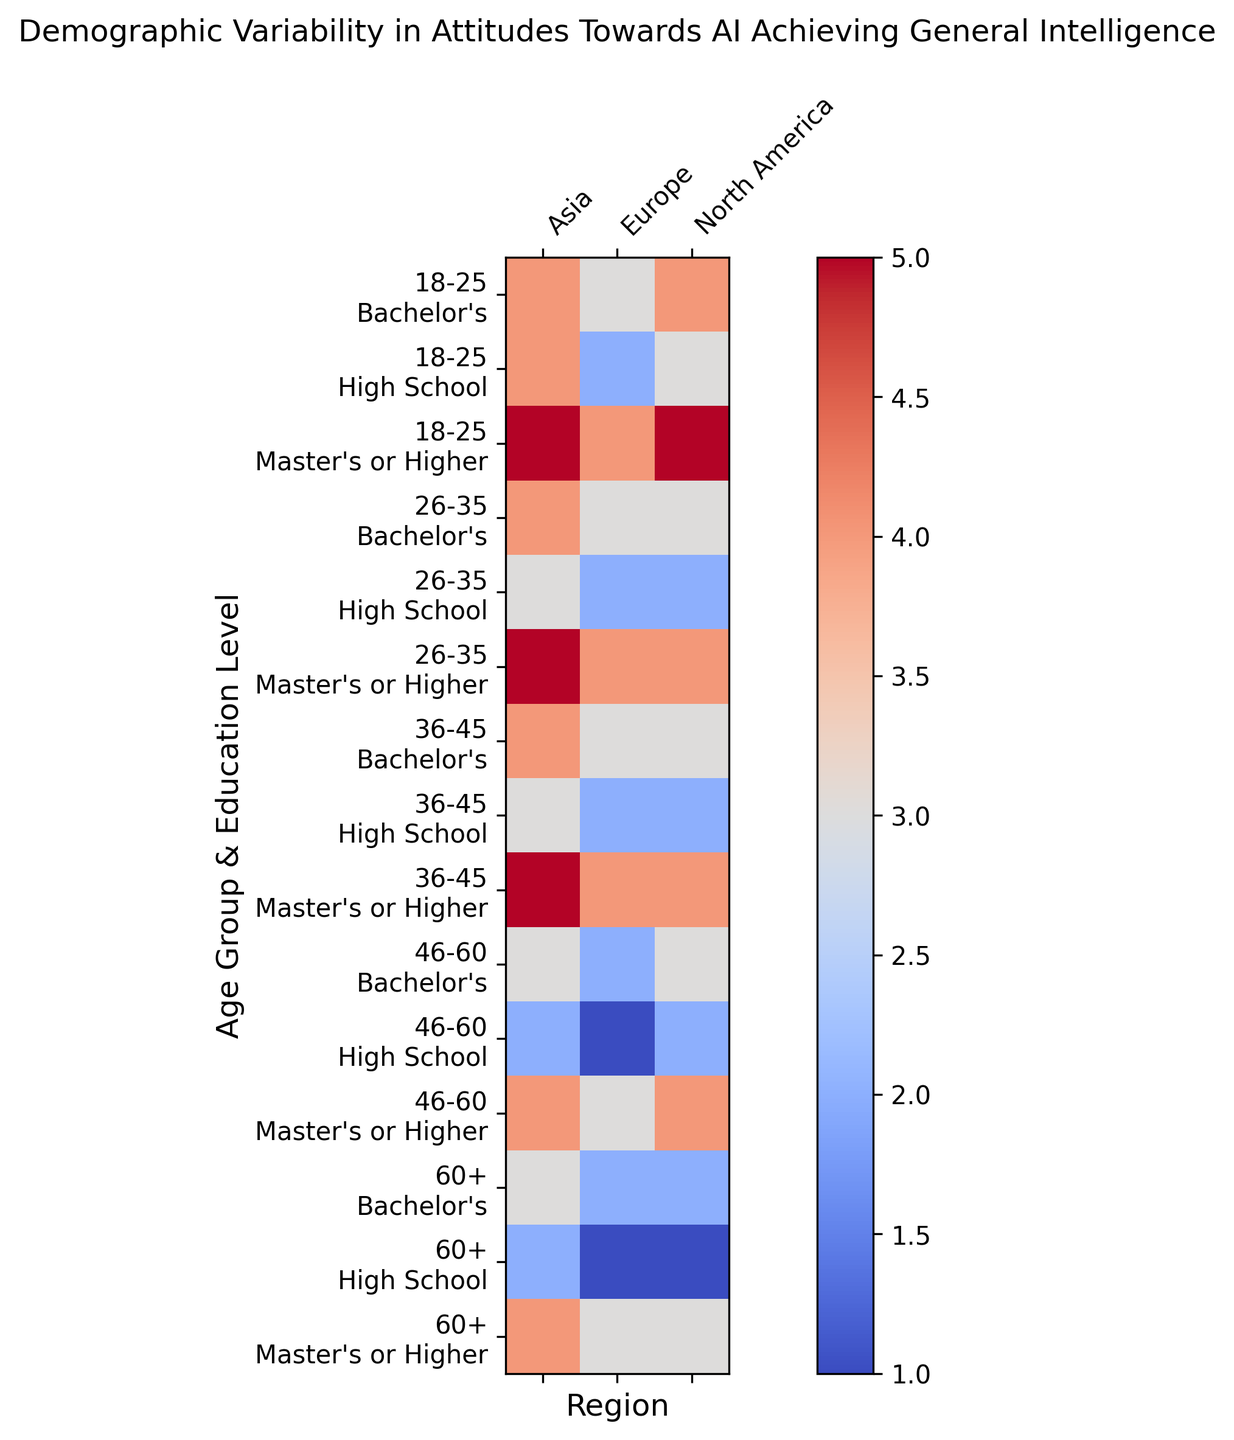Which age group and education level in North America exhibit the highest average support level? To determine the group with the highest average support level in North America, we look at the color gradient on the heatmap for North America and identify the deepest color, which corresponds to the highest numerical value. Upon inspection, the deepest color is displayed for the younger age groups with higher education levels.
Answer: 18-25, Master's or Higher How does the average support level for AI achieving general intelligence differ between Europe and Asia for the age group 46-60 with high school education? Compare the colors in the heatmap for 46-60, High School in both Europe and Asia. In Europe, the square is relatively pale, indicating a lower support level, while in Asia, the square is slightly darker.
Answer: Europe: 1, Asia: 2 What is the average support level for the age group 26-35 with a Bachelor's degree across all regions? To find this, locate the row for 26-35, Bachelor's and then look across all columns for North America, Europe, and Asia. Sum the support levels and divide by the number of regions.
Answer: (3+3+4)/3 = 3.33 Is there any age group in any region where the support level is consistently the same across all education levels? Look for rows where within a specific region, the color is uniform across different educational levels. Notice that in North America and Europe, there are variations, but in Asia for age group 18-25, the colors are very close if not uniform across education levels.
Answer: 18-25 in Asia Which region exhibits the most variability in support levels for the age group 60+ across different educational levels? Check the range of colors from lightest to darkest for the age group 60+ across the education levels within each region. Europe shows almost no variability, Asia shows more, and North America shows the highest variability.
Answer: North America Among the age groups 36-45 and 46-60, which group demonstrates higher support levels in Asia for those with a Bachelor’s degree? Compare the brightness of the corresponding squares in the columns for Asia between the two rows. The 36-45, Bachelor's square is darker compared to the 46-60, Bachelor's square, indicating a higher support level.
Answer: 36-45 What is the sum of the support levels for the age group 18-25 across all education levels in Europe? Extract the support levels for 18-25 across High School, Bachelor's, and Master's or Higher in Europe and sum them.
Answer: 2+3+4 = 9 